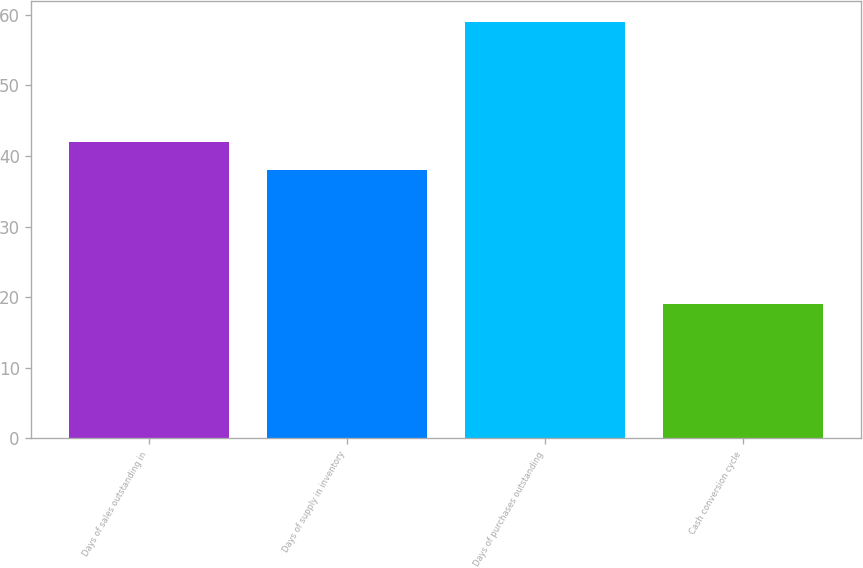Convert chart. <chart><loc_0><loc_0><loc_500><loc_500><bar_chart><fcel>Days of sales outstanding in<fcel>Days of supply in inventory<fcel>Days of purchases outstanding<fcel>Cash conversion cycle<nl><fcel>42<fcel>38<fcel>59<fcel>19<nl></chart> 